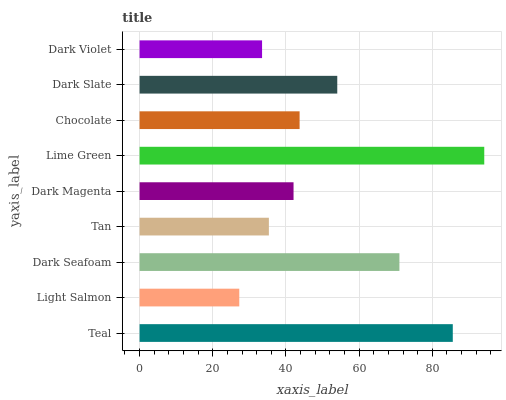Is Light Salmon the minimum?
Answer yes or no. Yes. Is Lime Green the maximum?
Answer yes or no. Yes. Is Dark Seafoam the minimum?
Answer yes or no. No. Is Dark Seafoam the maximum?
Answer yes or no. No. Is Dark Seafoam greater than Light Salmon?
Answer yes or no. Yes. Is Light Salmon less than Dark Seafoam?
Answer yes or no. Yes. Is Light Salmon greater than Dark Seafoam?
Answer yes or no. No. Is Dark Seafoam less than Light Salmon?
Answer yes or no. No. Is Chocolate the high median?
Answer yes or no. Yes. Is Chocolate the low median?
Answer yes or no. Yes. Is Light Salmon the high median?
Answer yes or no. No. Is Dark Seafoam the low median?
Answer yes or no. No. 